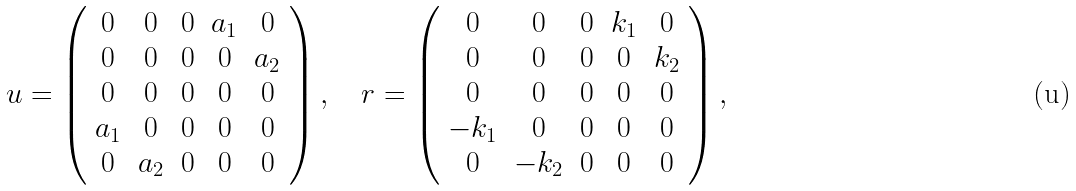<formula> <loc_0><loc_0><loc_500><loc_500>u = \left ( \begin{array} { c c c c c } 0 & 0 & 0 & a _ { 1 } & 0 \\ 0 & 0 & 0 & 0 & a _ { 2 } \\ 0 & 0 & 0 & 0 & 0 \\ a _ { 1 } & 0 & 0 & 0 & 0 \\ 0 & a _ { 2 } & 0 & 0 & 0 \\ \end{array} \right ) , \quad r = \left ( \begin{array} { c c c c c } 0 & 0 & 0 & k _ { 1 } & 0 \\ 0 & 0 & 0 & 0 & k _ { 2 } \\ 0 & 0 & 0 & 0 & 0 \\ - k _ { 1 } & 0 & 0 & 0 & 0 \\ 0 & - k _ { 2 } & 0 & 0 & 0 \\ \end{array} \right ) ,</formula> 